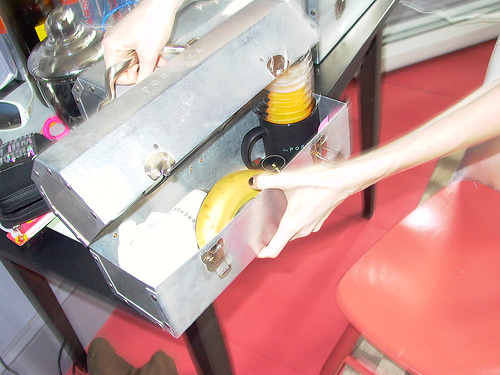<image>
Can you confirm if the metal box is behind the banana? No. The metal box is not behind the banana. From this viewpoint, the metal box appears to be positioned elsewhere in the scene. 